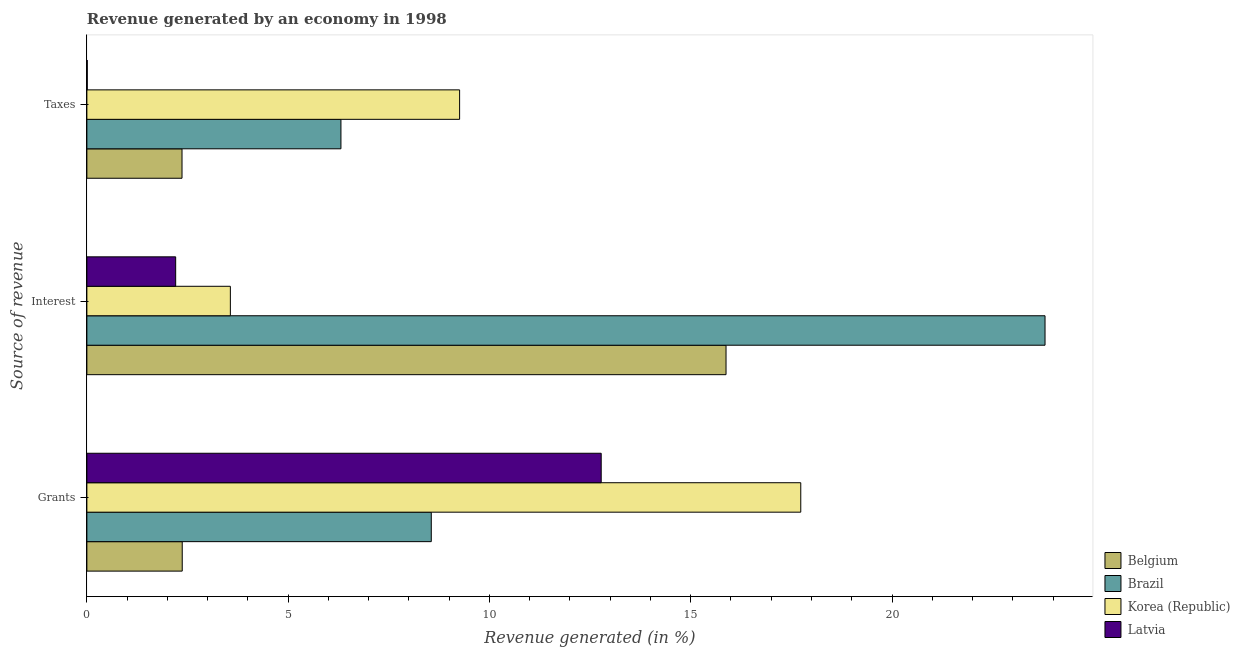How many groups of bars are there?
Offer a very short reply. 3. Are the number of bars per tick equal to the number of legend labels?
Keep it short and to the point. Yes. Are the number of bars on each tick of the Y-axis equal?
Make the answer very short. Yes. What is the label of the 1st group of bars from the top?
Give a very brief answer. Taxes. What is the percentage of revenue generated by grants in Belgium?
Ensure brevity in your answer.  2.37. Across all countries, what is the maximum percentage of revenue generated by taxes?
Provide a succinct answer. 9.26. Across all countries, what is the minimum percentage of revenue generated by interest?
Ensure brevity in your answer.  2.21. In which country was the percentage of revenue generated by grants maximum?
Keep it short and to the point. Korea (Republic). What is the total percentage of revenue generated by grants in the graph?
Keep it short and to the point. 41.43. What is the difference between the percentage of revenue generated by grants in Belgium and that in Latvia?
Keep it short and to the point. -10.41. What is the difference between the percentage of revenue generated by interest in Belgium and the percentage of revenue generated by grants in Korea (Republic)?
Give a very brief answer. -1.86. What is the average percentage of revenue generated by grants per country?
Provide a succinct answer. 10.36. What is the difference between the percentage of revenue generated by interest and percentage of revenue generated by taxes in Latvia?
Your answer should be very brief. 2.2. What is the ratio of the percentage of revenue generated by interest in Latvia to that in Belgium?
Your answer should be very brief. 0.14. Is the percentage of revenue generated by grants in Brazil less than that in Belgium?
Give a very brief answer. No. Is the difference between the percentage of revenue generated by taxes in Latvia and Brazil greater than the difference between the percentage of revenue generated by interest in Latvia and Brazil?
Keep it short and to the point. Yes. What is the difference between the highest and the second highest percentage of revenue generated by grants?
Your answer should be very brief. 4.96. What is the difference between the highest and the lowest percentage of revenue generated by grants?
Ensure brevity in your answer.  15.36. In how many countries, is the percentage of revenue generated by interest greater than the average percentage of revenue generated by interest taken over all countries?
Your answer should be very brief. 2. What does the 1st bar from the top in Taxes represents?
Ensure brevity in your answer.  Latvia. What does the 4th bar from the bottom in Grants represents?
Keep it short and to the point. Latvia. Is it the case that in every country, the sum of the percentage of revenue generated by grants and percentage of revenue generated by interest is greater than the percentage of revenue generated by taxes?
Your response must be concise. Yes. How many bars are there?
Give a very brief answer. 12. Are all the bars in the graph horizontal?
Ensure brevity in your answer.  Yes. What is the title of the graph?
Provide a succinct answer. Revenue generated by an economy in 1998. What is the label or title of the X-axis?
Your response must be concise. Revenue generated (in %). What is the label or title of the Y-axis?
Your answer should be very brief. Source of revenue. What is the Revenue generated (in %) of Belgium in Grants?
Ensure brevity in your answer.  2.37. What is the Revenue generated (in %) of Brazil in Grants?
Make the answer very short. 8.56. What is the Revenue generated (in %) in Korea (Republic) in Grants?
Offer a terse response. 17.73. What is the Revenue generated (in %) of Latvia in Grants?
Ensure brevity in your answer.  12.78. What is the Revenue generated (in %) of Belgium in Interest?
Your answer should be compact. 15.88. What is the Revenue generated (in %) of Brazil in Interest?
Provide a short and direct response. 23.8. What is the Revenue generated (in %) of Korea (Republic) in Interest?
Provide a succinct answer. 3.56. What is the Revenue generated (in %) of Latvia in Interest?
Offer a very short reply. 2.21. What is the Revenue generated (in %) of Belgium in Taxes?
Your answer should be very brief. 2.36. What is the Revenue generated (in %) of Brazil in Taxes?
Offer a very short reply. 6.31. What is the Revenue generated (in %) in Korea (Republic) in Taxes?
Offer a very short reply. 9.26. What is the Revenue generated (in %) of Latvia in Taxes?
Make the answer very short. 0.01. Across all Source of revenue, what is the maximum Revenue generated (in %) of Belgium?
Ensure brevity in your answer.  15.88. Across all Source of revenue, what is the maximum Revenue generated (in %) in Brazil?
Make the answer very short. 23.8. Across all Source of revenue, what is the maximum Revenue generated (in %) in Korea (Republic)?
Make the answer very short. 17.73. Across all Source of revenue, what is the maximum Revenue generated (in %) of Latvia?
Offer a terse response. 12.78. Across all Source of revenue, what is the minimum Revenue generated (in %) of Belgium?
Make the answer very short. 2.36. Across all Source of revenue, what is the minimum Revenue generated (in %) of Brazil?
Give a very brief answer. 6.31. Across all Source of revenue, what is the minimum Revenue generated (in %) of Korea (Republic)?
Provide a short and direct response. 3.56. Across all Source of revenue, what is the minimum Revenue generated (in %) in Latvia?
Keep it short and to the point. 0.01. What is the total Revenue generated (in %) in Belgium in the graph?
Make the answer very short. 20.61. What is the total Revenue generated (in %) of Brazil in the graph?
Keep it short and to the point. 38.67. What is the total Revenue generated (in %) of Korea (Republic) in the graph?
Offer a terse response. 30.56. What is the total Revenue generated (in %) in Latvia in the graph?
Offer a very short reply. 14.99. What is the difference between the Revenue generated (in %) of Belgium in Grants and that in Interest?
Your answer should be very brief. -13.51. What is the difference between the Revenue generated (in %) in Brazil in Grants and that in Interest?
Your response must be concise. -15.25. What is the difference between the Revenue generated (in %) of Korea (Republic) in Grants and that in Interest?
Offer a very short reply. 14.17. What is the difference between the Revenue generated (in %) of Latvia in Grants and that in Interest?
Provide a succinct answer. 10.57. What is the difference between the Revenue generated (in %) of Belgium in Grants and that in Taxes?
Offer a terse response. 0.01. What is the difference between the Revenue generated (in %) of Brazil in Grants and that in Taxes?
Your response must be concise. 2.24. What is the difference between the Revenue generated (in %) in Korea (Republic) in Grants and that in Taxes?
Ensure brevity in your answer.  8.47. What is the difference between the Revenue generated (in %) in Latvia in Grants and that in Taxes?
Offer a terse response. 12.77. What is the difference between the Revenue generated (in %) in Belgium in Interest and that in Taxes?
Offer a very short reply. 13.51. What is the difference between the Revenue generated (in %) of Brazil in Interest and that in Taxes?
Your response must be concise. 17.49. What is the difference between the Revenue generated (in %) in Korea (Republic) in Interest and that in Taxes?
Offer a very short reply. -5.69. What is the difference between the Revenue generated (in %) in Latvia in Interest and that in Taxes?
Offer a terse response. 2.2. What is the difference between the Revenue generated (in %) of Belgium in Grants and the Revenue generated (in %) of Brazil in Interest?
Ensure brevity in your answer.  -21.43. What is the difference between the Revenue generated (in %) of Belgium in Grants and the Revenue generated (in %) of Korea (Republic) in Interest?
Your answer should be very brief. -1.2. What is the difference between the Revenue generated (in %) in Belgium in Grants and the Revenue generated (in %) in Latvia in Interest?
Your answer should be compact. 0.16. What is the difference between the Revenue generated (in %) of Brazil in Grants and the Revenue generated (in %) of Korea (Republic) in Interest?
Provide a short and direct response. 4.99. What is the difference between the Revenue generated (in %) of Brazil in Grants and the Revenue generated (in %) of Latvia in Interest?
Your answer should be compact. 6.35. What is the difference between the Revenue generated (in %) of Korea (Republic) in Grants and the Revenue generated (in %) of Latvia in Interest?
Provide a succinct answer. 15.53. What is the difference between the Revenue generated (in %) of Belgium in Grants and the Revenue generated (in %) of Brazil in Taxes?
Provide a short and direct response. -3.94. What is the difference between the Revenue generated (in %) in Belgium in Grants and the Revenue generated (in %) in Korea (Republic) in Taxes?
Offer a very short reply. -6.89. What is the difference between the Revenue generated (in %) in Belgium in Grants and the Revenue generated (in %) in Latvia in Taxes?
Your answer should be compact. 2.36. What is the difference between the Revenue generated (in %) in Brazil in Grants and the Revenue generated (in %) in Korea (Republic) in Taxes?
Offer a very short reply. -0.7. What is the difference between the Revenue generated (in %) in Brazil in Grants and the Revenue generated (in %) in Latvia in Taxes?
Give a very brief answer. 8.55. What is the difference between the Revenue generated (in %) in Korea (Republic) in Grants and the Revenue generated (in %) in Latvia in Taxes?
Offer a very short reply. 17.72. What is the difference between the Revenue generated (in %) of Belgium in Interest and the Revenue generated (in %) of Brazil in Taxes?
Your answer should be compact. 9.57. What is the difference between the Revenue generated (in %) of Belgium in Interest and the Revenue generated (in %) of Korea (Republic) in Taxes?
Your response must be concise. 6.62. What is the difference between the Revenue generated (in %) of Belgium in Interest and the Revenue generated (in %) of Latvia in Taxes?
Your answer should be compact. 15.87. What is the difference between the Revenue generated (in %) in Brazil in Interest and the Revenue generated (in %) in Korea (Republic) in Taxes?
Offer a terse response. 14.54. What is the difference between the Revenue generated (in %) of Brazil in Interest and the Revenue generated (in %) of Latvia in Taxes?
Make the answer very short. 23.79. What is the difference between the Revenue generated (in %) of Korea (Republic) in Interest and the Revenue generated (in %) of Latvia in Taxes?
Ensure brevity in your answer.  3.56. What is the average Revenue generated (in %) of Belgium per Source of revenue?
Give a very brief answer. 6.87. What is the average Revenue generated (in %) in Brazil per Source of revenue?
Provide a succinct answer. 12.89. What is the average Revenue generated (in %) of Korea (Republic) per Source of revenue?
Provide a succinct answer. 10.19. What is the average Revenue generated (in %) of Latvia per Source of revenue?
Offer a terse response. 5. What is the difference between the Revenue generated (in %) of Belgium and Revenue generated (in %) of Brazil in Grants?
Provide a succinct answer. -6.19. What is the difference between the Revenue generated (in %) in Belgium and Revenue generated (in %) in Korea (Republic) in Grants?
Your answer should be very brief. -15.36. What is the difference between the Revenue generated (in %) of Belgium and Revenue generated (in %) of Latvia in Grants?
Offer a terse response. -10.41. What is the difference between the Revenue generated (in %) of Brazil and Revenue generated (in %) of Korea (Republic) in Grants?
Keep it short and to the point. -9.18. What is the difference between the Revenue generated (in %) of Brazil and Revenue generated (in %) of Latvia in Grants?
Your answer should be compact. -4.22. What is the difference between the Revenue generated (in %) in Korea (Republic) and Revenue generated (in %) in Latvia in Grants?
Offer a terse response. 4.96. What is the difference between the Revenue generated (in %) of Belgium and Revenue generated (in %) of Brazil in Interest?
Keep it short and to the point. -7.92. What is the difference between the Revenue generated (in %) of Belgium and Revenue generated (in %) of Korea (Republic) in Interest?
Your answer should be compact. 12.31. What is the difference between the Revenue generated (in %) of Belgium and Revenue generated (in %) of Latvia in Interest?
Provide a succinct answer. 13.67. What is the difference between the Revenue generated (in %) of Brazil and Revenue generated (in %) of Korea (Republic) in Interest?
Offer a very short reply. 20.24. What is the difference between the Revenue generated (in %) in Brazil and Revenue generated (in %) in Latvia in Interest?
Provide a succinct answer. 21.6. What is the difference between the Revenue generated (in %) of Korea (Republic) and Revenue generated (in %) of Latvia in Interest?
Your response must be concise. 1.36. What is the difference between the Revenue generated (in %) of Belgium and Revenue generated (in %) of Brazil in Taxes?
Make the answer very short. -3.95. What is the difference between the Revenue generated (in %) in Belgium and Revenue generated (in %) in Korea (Republic) in Taxes?
Keep it short and to the point. -6.9. What is the difference between the Revenue generated (in %) of Belgium and Revenue generated (in %) of Latvia in Taxes?
Your response must be concise. 2.35. What is the difference between the Revenue generated (in %) in Brazil and Revenue generated (in %) in Korea (Republic) in Taxes?
Ensure brevity in your answer.  -2.95. What is the difference between the Revenue generated (in %) of Brazil and Revenue generated (in %) of Latvia in Taxes?
Your response must be concise. 6.3. What is the difference between the Revenue generated (in %) in Korea (Republic) and Revenue generated (in %) in Latvia in Taxes?
Keep it short and to the point. 9.25. What is the ratio of the Revenue generated (in %) of Belgium in Grants to that in Interest?
Keep it short and to the point. 0.15. What is the ratio of the Revenue generated (in %) of Brazil in Grants to that in Interest?
Make the answer very short. 0.36. What is the ratio of the Revenue generated (in %) of Korea (Republic) in Grants to that in Interest?
Offer a terse response. 4.98. What is the ratio of the Revenue generated (in %) of Latvia in Grants to that in Interest?
Your response must be concise. 5.79. What is the ratio of the Revenue generated (in %) of Brazil in Grants to that in Taxes?
Ensure brevity in your answer.  1.36. What is the ratio of the Revenue generated (in %) of Korea (Republic) in Grants to that in Taxes?
Ensure brevity in your answer.  1.92. What is the ratio of the Revenue generated (in %) in Latvia in Grants to that in Taxes?
Provide a succinct answer. 1408. What is the ratio of the Revenue generated (in %) in Belgium in Interest to that in Taxes?
Provide a short and direct response. 6.72. What is the ratio of the Revenue generated (in %) of Brazil in Interest to that in Taxes?
Make the answer very short. 3.77. What is the ratio of the Revenue generated (in %) in Korea (Republic) in Interest to that in Taxes?
Your answer should be compact. 0.39. What is the ratio of the Revenue generated (in %) in Latvia in Interest to that in Taxes?
Your response must be concise. 243.09. What is the difference between the highest and the second highest Revenue generated (in %) of Belgium?
Keep it short and to the point. 13.51. What is the difference between the highest and the second highest Revenue generated (in %) in Brazil?
Provide a succinct answer. 15.25. What is the difference between the highest and the second highest Revenue generated (in %) in Korea (Republic)?
Provide a succinct answer. 8.47. What is the difference between the highest and the second highest Revenue generated (in %) in Latvia?
Give a very brief answer. 10.57. What is the difference between the highest and the lowest Revenue generated (in %) of Belgium?
Your response must be concise. 13.51. What is the difference between the highest and the lowest Revenue generated (in %) in Brazil?
Keep it short and to the point. 17.49. What is the difference between the highest and the lowest Revenue generated (in %) of Korea (Republic)?
Give a very brief answer. 14.17. What is the difference between the highest and the lowest Revenue generated (in %) of Latvia?
Keep it short and to the point. 12.77. 